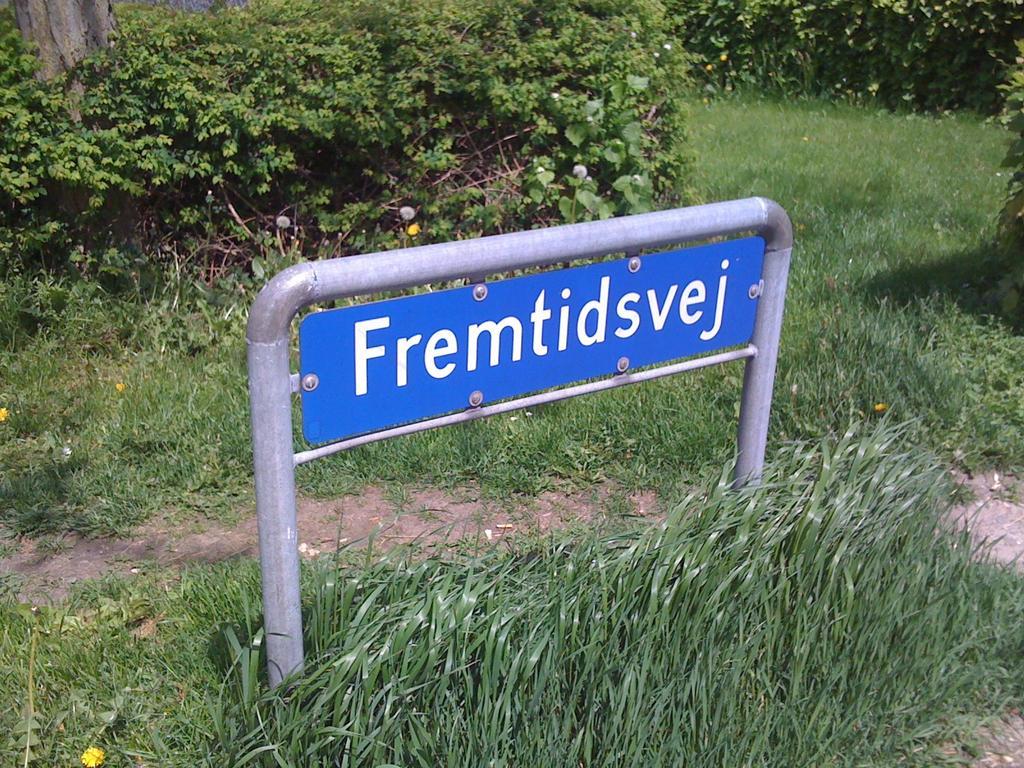How would you summarize this image in a sentence or two? In the center of the image there is a name board. At the bottom of the image there is grass. In the background of the image there are plants. There is a tree trunk. 